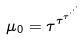<formula> <loc_0><loc_0><loc_500><loc_500>\mu _ { 0 } = \tau ^ { \tau ^ { \tau ^ { \cdot ^ { \cdot ^ { \cdot } } } } }</formula> 